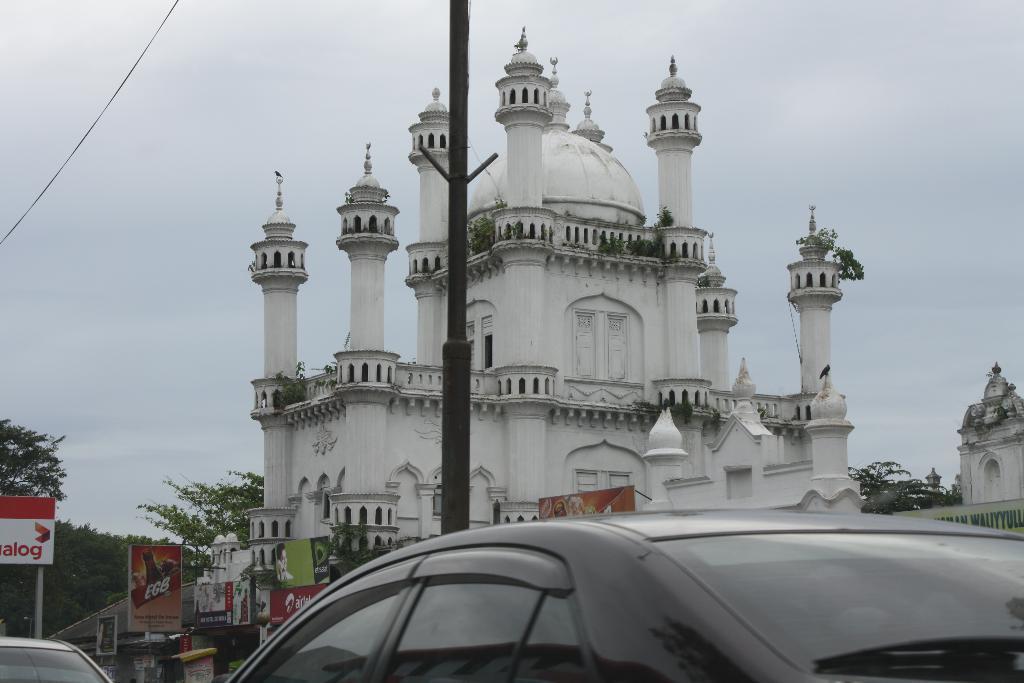Describe this image in one or two sentences. In this image, we can see ancient architecture, banners, trees, railings, pillars, plants and poles. At the bottom of the image, we can see the vehicles. In the background, there is the sky. 